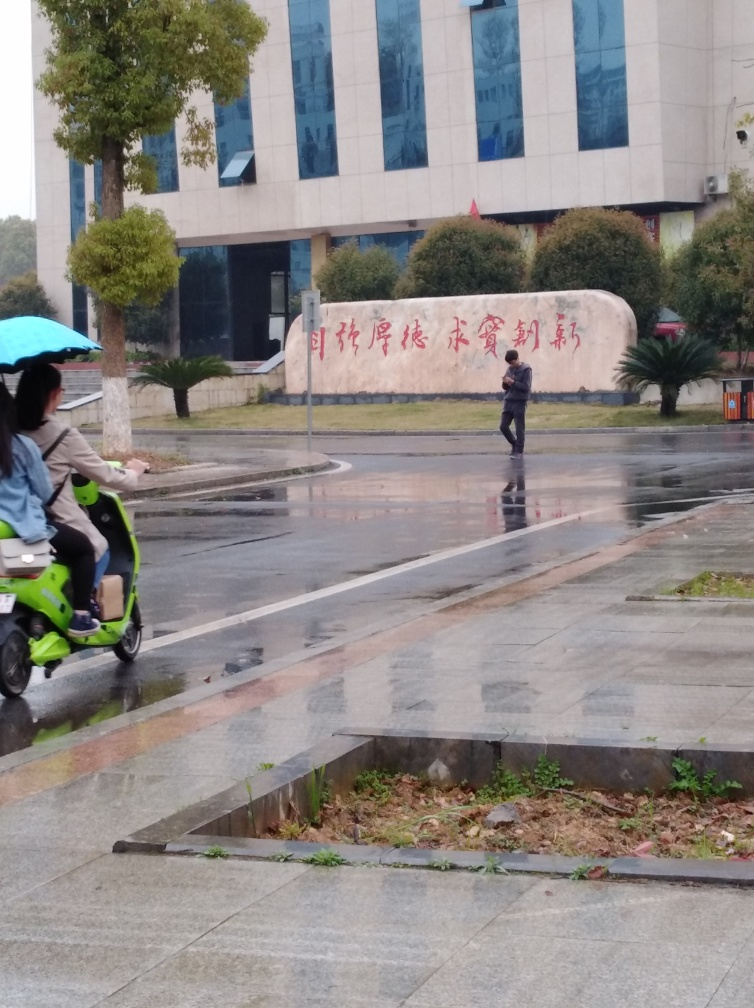What sort of activities might take place in this area on a day with better weather? On a day with better weather, the area might be bustling with activity. People could be walking to work or school, using the benches and wide pavements for leisure or commuting, and enjoying the outdoor environment. The open space in front of the building could serve as a gathering spot for social interactions or public events, given its prominent structure and the significant space it occupies. 